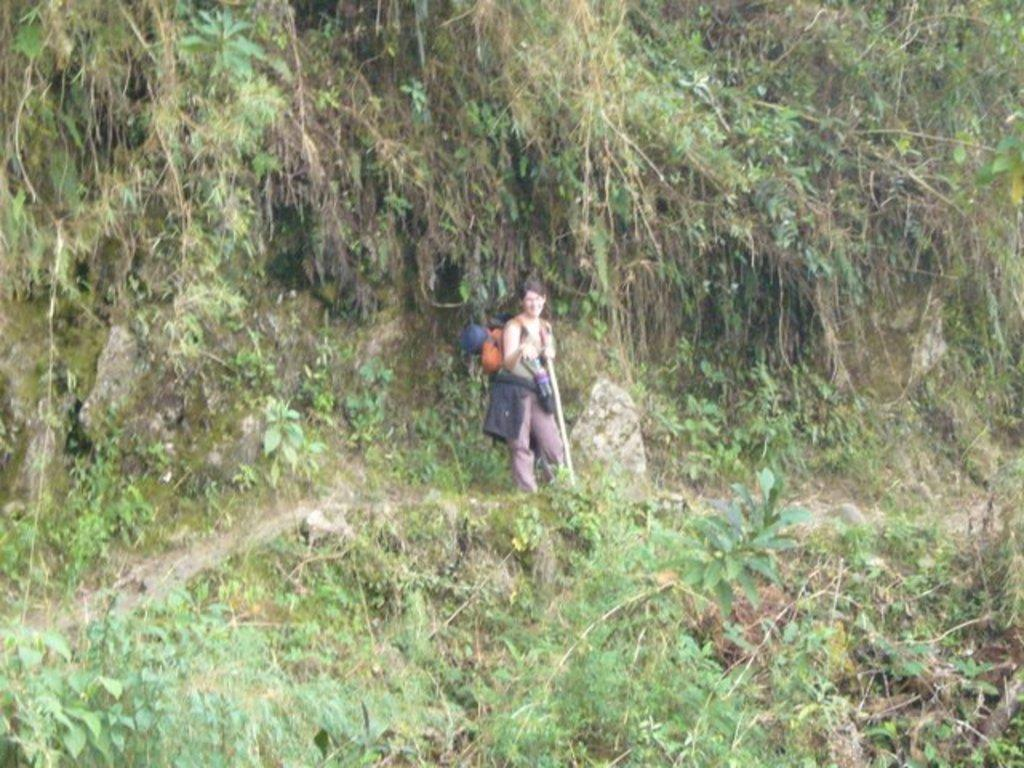Who is the main subject in the image? There is a lady in the center of the image. What is the lady wearing? The lady is wearing a bag. What is the lady holding in the image? The lady is holding some objects. What can be seen in the background of the image? There are trees and a hill visible in the background of the image. What type of meat is being prepared on the hill in the image? There is no meat or any indication of food preparation in the image. 